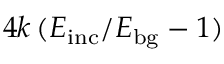Convert formula to latex. <formula><loc_0><loc_0><loc_500><loc_500>4 k \, ( E _ { i n c } / E _ { b g } - 1 )</formula> 